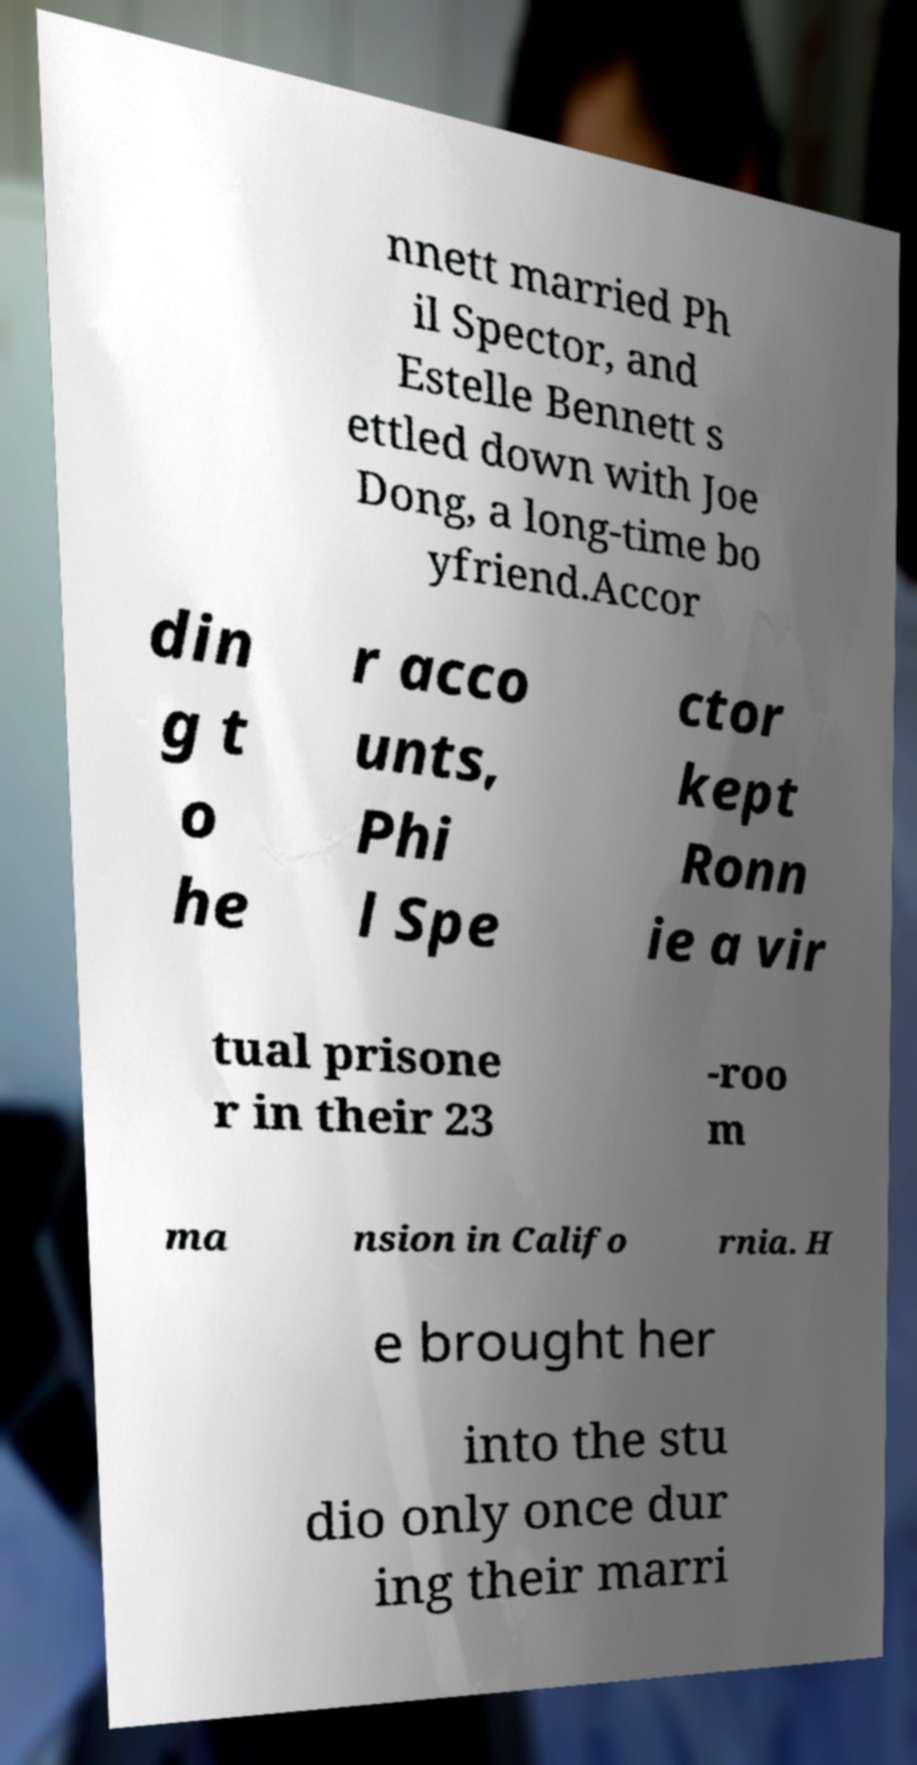Could you assist in decoding the text presented in this image and type it out clearly? nnett married Ph il Spector, and Estelle Bennett s ettled down with Joe Dong, a long-time bo yfriend.Accor din g t o he r acco unts, Phi l Spe ctor kept Ronn ie a vir tual prisone r in their 23 -roo m ma nsion in Califo rnia. H e brought her into the stu dio only once dur ing their marri 